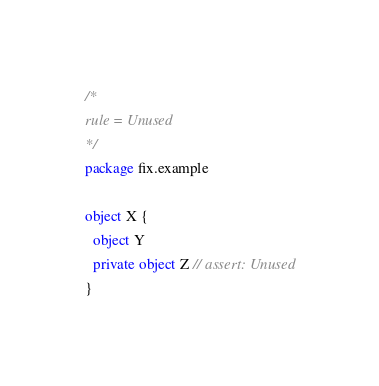Convert code to text. <code><loc_0><loc_0><loc_500><loc_500><_Scala_>/*
rule = Unused
*/
package fix.example

object X {
  object Y
  private object Z // assert: Unused
}
</code> 